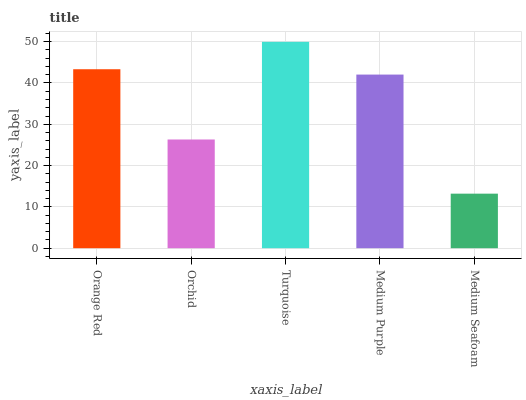Is Medium Seafoam the minimum?
Answer yes or no. Yes. Is Turquoise the maximum?
Answer yes or no. Yes. Is Orchid the minimum?
Answer yes or no. No. Is Orchid the maximum?
Answer yes or no. No. Is Orange Red greater than Orchid?
Answer yes or no. Yes. Is Orchid less than Orange Red?
Answer yes or no. Yes. Is Orchid greater than Orange Red?
Answer yes or no. No. Is Orange Red less than Orchid?
Answer yes or no. No. Is Medium Purple the high median?
Answer yes or no. Yes. Is Medium Purple the low median?
Answer yes or no. Yes. Is Turquoise the high median?
Answer yes or no. No. Is Turquoise the low median?
Answer yes or no. No. 